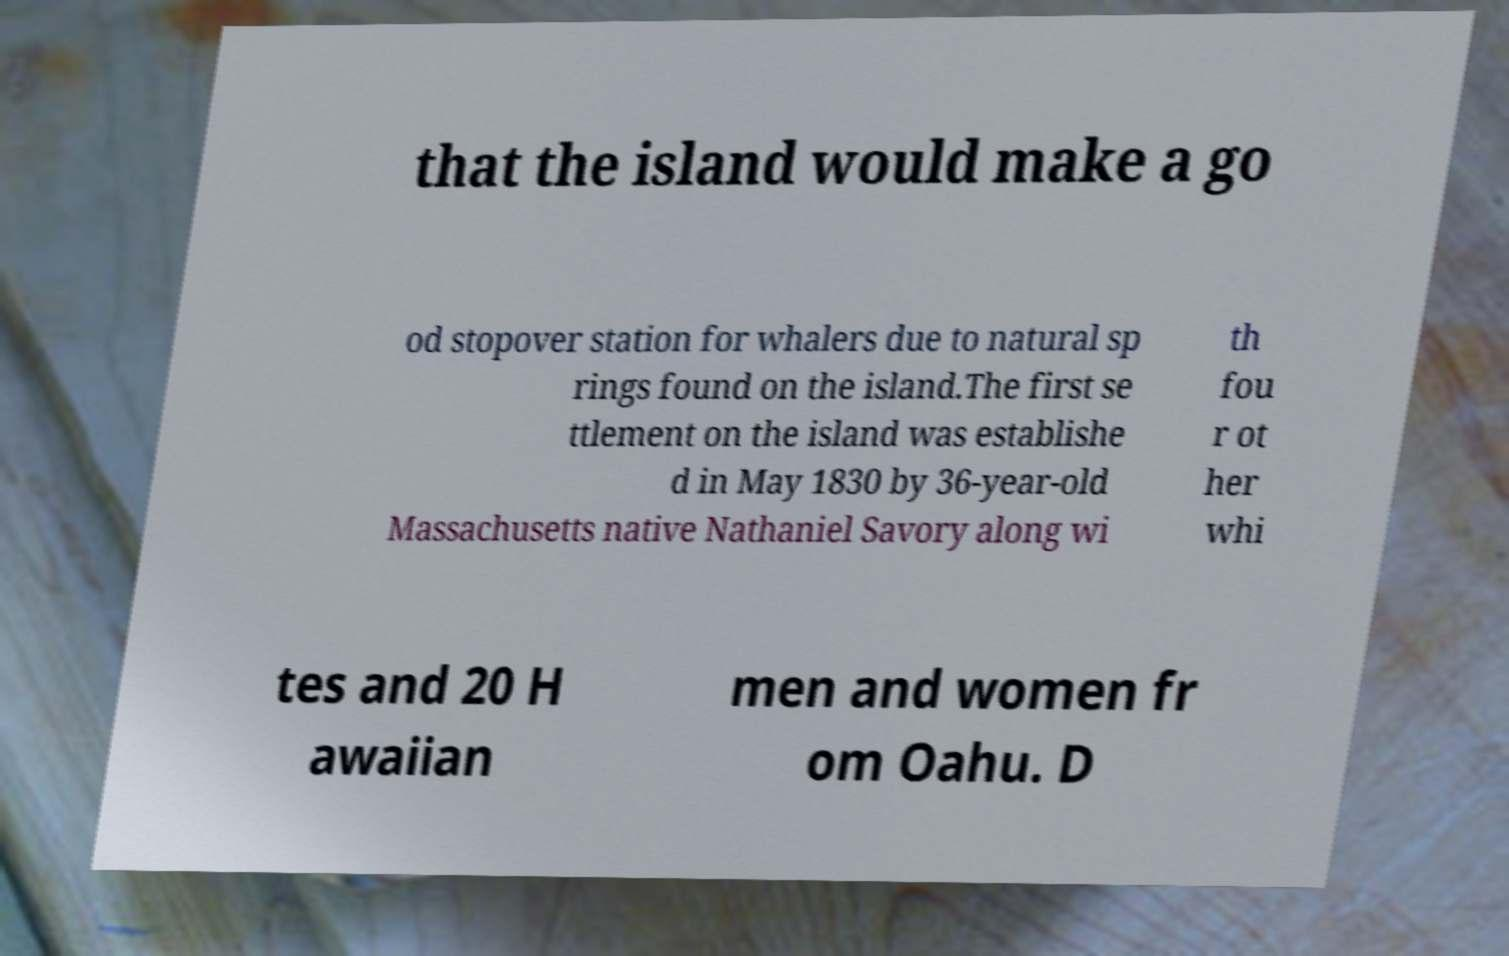Please read and relay the text visible in this image. What does it say? that the island would make a go od stopover station for whalers due to natural sp rings found on the island.The first se ttlement on the island was establishe d in May 1830 by 36-year-old Massachusetts native Nathaniel Savory along wi th fou r ot her whi tes and 20 H awaiian men and women fr om Oahu. D 